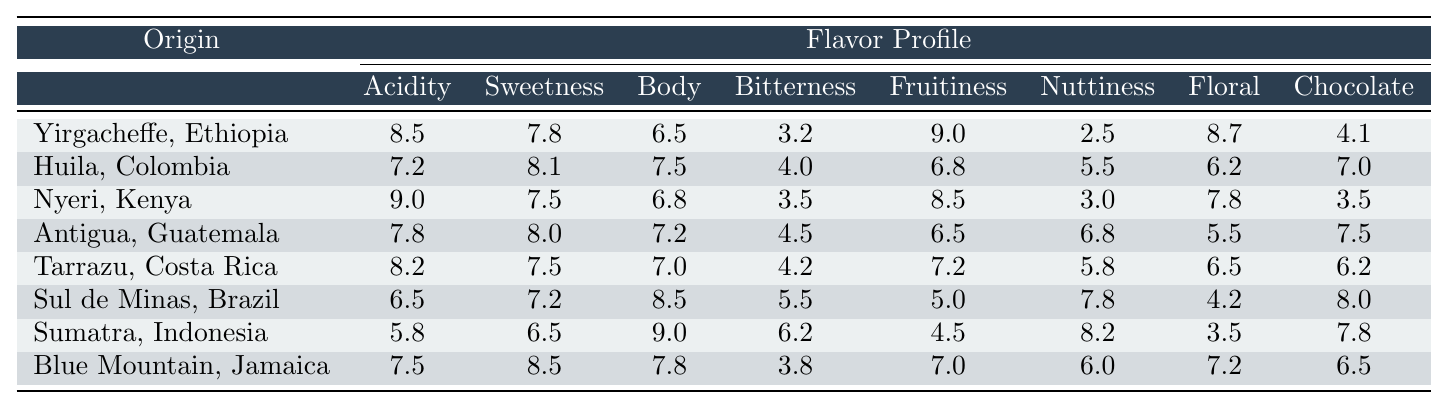What is the sweetness rating of Yirgacheffe, Ethiopia? From the table, I can see that the sweetness rating for Yirgacheffe, Ethiopia is listed as 7.8.
Answer: 7.8 Which coffee has the highest acidity rating? By comparing all the acidity ratings from each region, Nyeri, Kenya has the highest acidity rating at 9.0.
Answer: Nyeri, Kenya What is the average body rating of all coffees listed? To find the average body rating, I sum the body ratings (6.5 + 7.5 + 6.8 + 7.2 + 7.0 + 8.5 + 9.0 + 7.8 = 60.5) and divide by the number of coffees (8). The average body rating is 60.5 / 8 = 7.56.
Answer: 7.56 Which coffee has the lowest bitterness rating? When examining the bitterness ratings, Yirgacheffe, Ethiopia has the lowest bitterness rating of 3.2.
Answer: Yirgacheffe, Ethiopia Is the floral rating for Tarrazu, Costa Rica higher than that of Sul de Minas, Brazil? The floral rating for Tarrazu is 6.5 and for Sul de Minas is 4.2. Since 6.5 is greater than 4.2, the floral rating for Tarrazu is indeed higher.
Answer: Yes How does the fruitiness of Huila, Colombia compare to the average fruitiness of all coffees? The fruitiness rating for Huila is 6.8. To find the average, I sum all the fruitiness ratings (9.0 + 6.8 + 8.5 + 6.5 + 7.2 + 5.0 + 4.5 + 7.0 = 54.5) and divide by 8, resulting in an average of 6.81. Since 6.8 is slightly less than 6.81, Huila is below average.
Answer: Below average Which coffee has the best overall rating considering sweetness, acidity, and body? I will evaluate the combined score of sweetness, acidity, and body for each coffee: Yirgacheffe (8.5+7.8+6.5=22.8), Huila (7.2+8.1+7.5=22.8), Nyeri (9+7.5+6.8=23.3), Antigua (7.8+8+7.2=23), Tarrazu (8.2+7.5+7=22.7), Sul de Minas (6.5+7.2+8.5=22.2), Sumatra (5.8+6.5+9=21.3), Blue Mountain (7.5+8.5+7.8=23.8). Blue Mountain, Jamaica has the highest combined total of 23.8.
Answer: Blue Mountain, Jamaica Are there more coffees with a sweetness rating higher than 7.5 than those below it? The coffees with sweetness ratings above 7.5 are Yirgacheffe (7.8), Huila (8.1), Antigua (8.0), Blue Mountain (8.5). The coffees below are Nyeri (7.5), Tarrazu (7.5), Sul de Minas (7.2), Sumatra (6.5). There are 4 with a higher rating and 4 below, so they are equal.
Answer: No What is the difference in the bitterness rating between the highest and lowest rated coffees? The highest bitterness rating is from Sul de Minas at 5.5, and the lowest is from Yirgacheffe at 3.2. The difference would be 5.5 - 3.2 = 2.3.
Answer: 2.3 